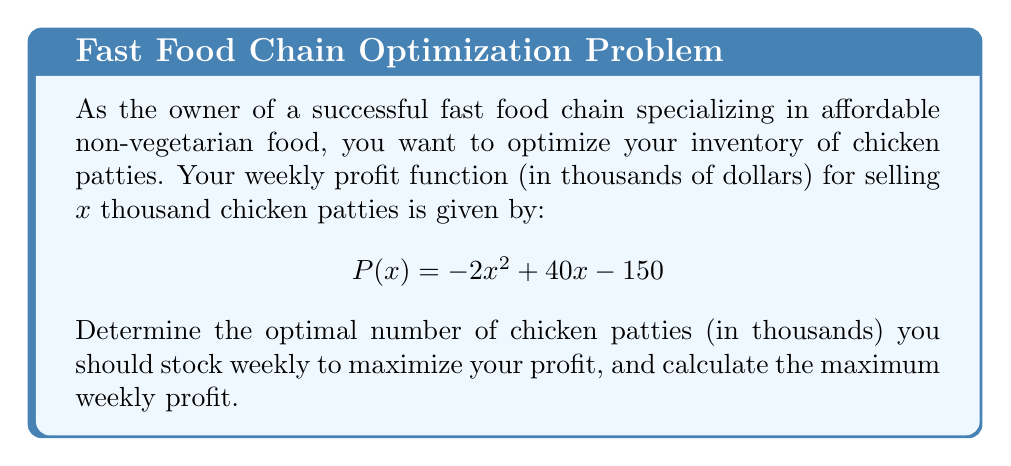Provide a solution to this math problem. To solve this problem, we'll follow these steps:

1) The profit function $P(x)$ is a quadratic function. The optimal number of chicken patties will occur at the vertex of this parabola.

2) For a quadratic function in the form $f(x) = ax^2 + bx + c$, the x-coordinate of the vertex is given by $x = -\frac{b}{2a}$.

3) In our case, $a = -2$, $b = 40$, and $c = -150$. Let's substitute these into the vertex formula:

   $x = -\frac{40}{2(-2)} = -\frac{40}{-4} = 10$

4) This means the optimal number of chicken patties to stock is 10 thousand per week.

5) To find the maximum profit, we substitute $x = 10$ into the original profit function:

   $P(10) = -2(10)^2 + 40(10) - 150$
   $= -2(100) + 400 - 150$
   $= -200 + 400 - 150$
   $= 50$

6) Therefore, the maximum weekly profit is $50 thousand, or $50,000.
Answer: The optimal number of chicken patties to stock weekly is 10,000, and the maximum weekly profit is $50,000. 